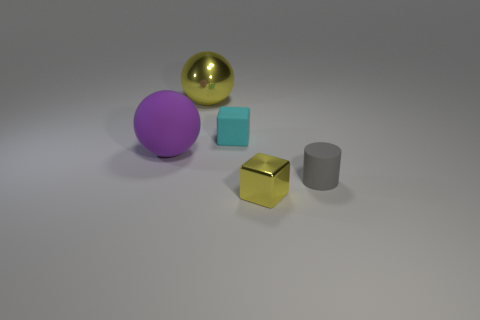Add 2 blue rubber cylinders. How many objects exist? 7 Subtract all cylinders. How many objects are left? 4 Add 5 gray rubber objects. How many gray rubber objects are left? 6 Add 1 gray rubber balls. How many gray rubber balls exist? 1 Subtract 0 yellow cylinders. How many objects are left? 5 Subtract all purple things. Subtract all matte things. How many objects are left? 1 